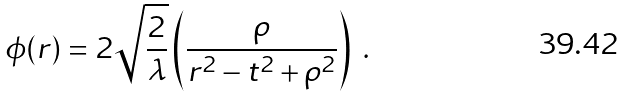<formula> <loc_0><loc_0><loc_500><loc_500>\phi ( r ) = 2 \sqrt { \frac { 2 } { \lambda } } \left ( { \frac { \rho } { r ^ { 2 } - t ^ { 2 } + \rho ^ { 2 } } } \right ) \ .</formula> 